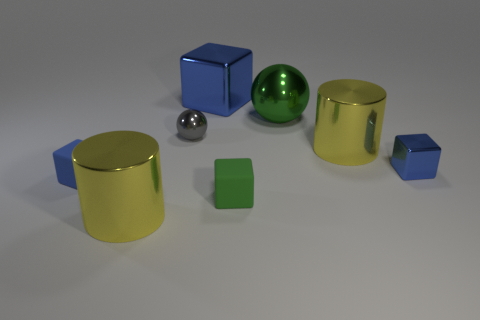Is the number of blue rubber blocks that are to the right of the big blue cube greater than the number of large blue objects on the left side of the tiny blue rubber thing?
Your answer should be very brief. No. How many other things are there of the same color as the large cube?
Offer a very short reply. 2. There is a big cube; is its color the same as the metallic thing that is to the left of the gray ball?
Make the answer very short. No. There is a large cylinder in front of the blue rubber cube; how many tiny blue matte blocks are in front of it?
Offer a very short reply. 0. Is there any other thing that is made of the same material as the tiny green thing?
Provide a succinct answer. Yes. What is the tiny blue block on the right side of the large yellow object in front of the blue object that is left of the big block made of?
Offer a very short reply. Metal. What is the large object that is to the right of the small gray metal thing and in front of the tiny gray metal ball made of?
Keep it short and to the point. Metal. What number of other matte objects have the same shape as the blue matte object?
Your answer should be compact. 1. How big is the sphere that is on the right side of the cube that is behind the green sphere?
Offer a very short reply. Large. Does the shiny cube in front of the green ball have the same color as the big cylinder that is left of the green shiny thing?
Offer a very short reply. No. 